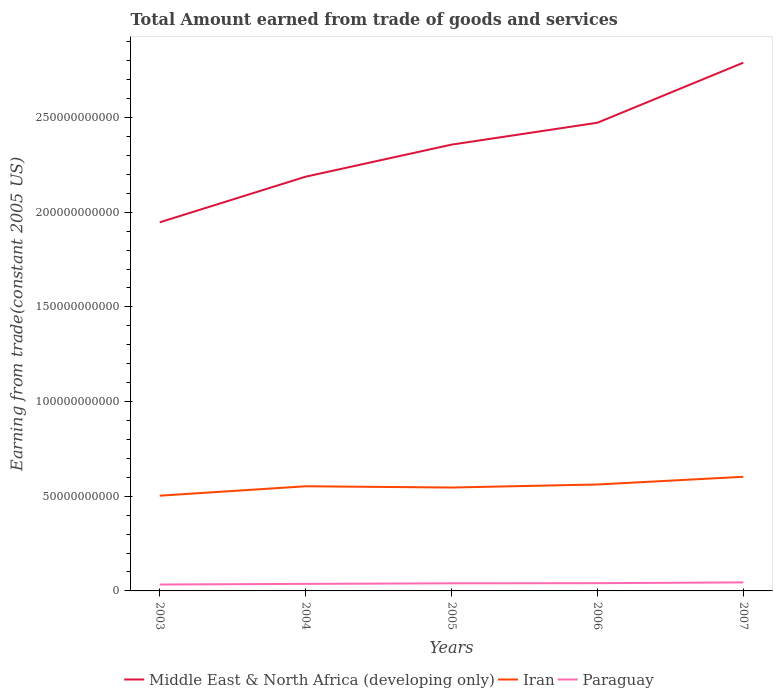How many different coloured lines are there?
Your response must be concise. 3. Across all years, what is the maximum total amount earned by trading goods and services in Middle East & North Africa (developing only)?
Keep it short and to the point. 1.95e+11. What is the total total amount earned by trading goods and services in Paraguay in the graph?
Make the answer very short. -3.79e+08. What is the difference between the highest and the second highest total amount earned by trading goods and services in Middle East & North Africa (developing only)?
Offer a very short reply. 8.43e+1. Is the total amount earned by trading goods and services in Middle East & North Africa (developing only) strictly greater than the total amount earned by trading goods and services in Paraguay over the years?
Keep it short and to the point. No. Does the graph contain any zero values?
Your answer should be very brief. No. Does the graph contain grids?
Your answer should be compact. No. What is the title of the graph?
Provide a succinct answer. Total Amount earned from trade of goods and services. What is the label or title of the Y-axis?
Offer a very short reply. Earning from trade(constant 2005 US). What is the Earning from trade(constant 2005 US) of Middle East & North Africa (developing only) in 2003?
Make the answer very short. 1.95e+11. What is the Earning from trade(constant 2005 US) in Iran in 2003?
Offer a very short reply. 5.03e+1. What is the Earning from trade(constant 2005 US) of Paraguay in 2003?
Provide a short and direct response. 3.38e+09. What is the Earning from trade(constant 2005 US) in Middle East & North Africa (developing only) in 2004?
Make the answer very short. 2.19e+11. What is the Earning from trade(constant 2005 US) of Iran in 2004?
Your response must be concise. 5.53e+1. What is the Earning from trade(constant 2005 US) in Paraguay in 2004?
Ensure brevity in your answer.  3.72e+09. What is the Earning from trade(constant 2005 US) in Middle East & North Africa (developing only) in 2005?
Your answer should be very brief. 2.36e+11. What is the Earning from trade(constant 2005 US) in Iran in 2005?
Your response must be concise. 5.46e+1. What is the Earning from trade(constant 2005 US) of Paraguay in 2005?
Provide a succinct answer. 4.02e+09. What is the Earning from trade(constant 2005 US) in Middle East & North Africa (developing only) in 2006?
Give a very brief answer. 2.47e+11. What is the Earning from trade(constant 2005 US) of Iran in 2006?
Your response must be concise. 5.62e+1. What is the Earning from trade(constant 2005 US) in Paraguay in 2006?
Keep it short and to the point. 4.10e+09. What is the Earning from trade(constant 2005 US) in Middle East & North Africa (developing only) in 2007?
Offer a terse response. 2.79e+11. What is the Earning from trade(constant 2005 US) of Iran in 2007?
Keep it short and to the point. 6.03e+1. What is the Earning from trade(constant 2005 US) of Paraguay in 2007?
Your response must be concise. 4.49e+09. Across all years, what is the maximum Earning from trade(constant 2005 US) of Middle East & North Africa (developing only)?
Offer a very short reply. 2.79e+11. Across all years, what is the maximum Earning from trade(constant 2005 US) of Iran?
Your answer should be very brief. 6.03e+1. Across all years, what is the maximum Earning from trade(constant 2005 US) of Paraguay?
Your answer should be very brief. 4.49e+09. Across all years, what is the minimum Earning from trade(constant 2005 US) of Middle East & North Africa (developing only)?
Offer a very short reply. 1.95e+11. Across all years, what is the minimum Earning from trade(constant 2005 US) in Iran?
Make the answer very short. 5.03e+1. Across all years, what is the minimum Earning from trade(constant 2005 US) of Paraguay?
Your answer should be compact. 3.38e+09. What is the total Earning from trade(constant 2005 US) in Middle East & North Africa (developing only) in the graph?
Provide a short and direct response. 1.18e+12. What is the total Earning from trade(constant 2005 US) of Iran in the graph?
Provide a short and direct response. 2.77e+11. What is the total Earning from trade(constant 2005 US) in Paraguay in the graph?
Make the answer very short. 1.97e+1. What is the difference between the Earning from trade(constant 2005 US) in Middle East & North Africa (developing only) in 2003 and that in 2004?
Your response must be concise. -2.41e+1. What is the difference between the Earning from trade(constant 2005 US) of Iran in 2003 and that in 2004?
Keep it short and to the point. -4.98e+09. What is the difference between the Earning from trade(constant 2005 US) of Paraguay in 2003 and that in 2004?
Ensure brevity in your answer.  -3.34e+08. What is the difference between the Earning from trade(constant 2005 US) in Middle East & North Africa (developing only) in 2003 and that in 2005?
Provide a succinct answer. -4.10e+1. What is the difference between the Earning from trade(constant 2005 US) of Iran in 2003 and that in 2005?
Offer a very short reply. -4.31e+09. What is the difference between the Earning from trade(constant 2005 US) in Paraguay in 2003 and that in 2005?
Provide a short and direct response. -6.34e+08. What is the difference between the Earning from trade(constant 2005 US) in Middle East & North Africa (developing only) in 2003 and that in 2006?
Your answer should be compact. -5.26e+1. What is the difference between the Earning from trade(constant 2005 US) in Iran in 2003 and that in 2006?
Provide a succinct answer. -5.92e+09. What is the difference between the Earning from trade(constant 2005 US) of Paraguay in 2003 and that in 2006?
Make the answer very short. -7.12e+08. What is the difference between the Earning from trade(constant 2005 US) of Middle East & North Africa (developing only) in 2003 and that in 2007?
Keep it short and to the point. -8.43e+1. What is the difference between the Earning from trade(constant 2005 US) of Iran in 2003 and that in 2007?
Ensure brevity in your answer.  -9.98e+09. What is the difference between the Earning from trade(constant 2005 US) of Paraguay in 2003 and that in 2007?
Ensure brevity in your answer.  -1.11e+09. What is the difference between the Earning from trade(constant 2005 US) of Middle East & North Africa (developing only) in 2004 and that in 2005?
Provide a succinct answer. -1.69e+1. What is the difference between the Earning from trade(constant 2005 US) of Iran in 2004 and that in 2005?
Your answer should be compact. 6.70e+08. What is the difference between the Earning from trade(constant 2005 US) of Paraguay in 2004 and that in 2005?
Provide a short and direct response. -3.00e+08. What is the difference between the Earning from trade(constant 2005 US) in Middle East & North Africa (developing only) in 2004 and that in 2006?
Keep it short and to the point. -2.85e+1. What is the difference between the Earning from trade(constant 2005 US) in Iran in 2004 and that in 2006?
Offer a terse response. -9.44e+08. What is the difference between the Earning from trade(constant 2005 US) of Paraguay in 2004 and that in 2006?
Provide a succinct answer. -3.79e+08. What is the difference between the Earning from trade(constant 2005 US) of Middle East & North Africa (developing only) in 2004 and that in 2007?
Your response must be concise. -6.02e+1. What is the difference between the Earning from trade(constant 2005 US) of Iran in 2004 and that in 2007?
Your answer should be compact. -5.00e+09. What is the difference between the Earning from trade(constant 2005 US) in Paraguay in 2004 and that in 2007?
Offer a very short reply. -7.75e+08. What is the difference between the Earning from trade(constant 2005 US) in Middle East & North Africa (developing only) in 2005 and that in 2006?
Offer a very short reply. -1.16e+1. What is the difference between the Earning from trade(constant 2005 US) in Iran in 2005 and that in 2006?
Offer a very short reply. -1.61e+09. What is the difference between the Earning from trade(constant 2005 US) in Paraguay in 2005 and that in 2006?
Offer a terse response. -7.84e+07. What is the difference between the Earning from trade(constant 2005 US) of Middle East & North Africa (developing only) in 2005 and that in 2007?
Provide a short and direct response. -4.33e+1. What is the difference between the Earning from trade(constant 2005 US) of Iran in 2005 and that in 2007?
Offer a terse response. -5.67e+09. What is the difference between the Earning from trade(constant 2005 US) in Paraguay in 2005 and that in 2007?
Offer a terse response. -4.75e+08. What is the difference between the Earning from trade(constant 2005 US) in Middle East & North Africa (developing only) in 2006 and that in 2007?
Your response must be concise. -3.17e+1. What is the difference between the Earning from trade(constant 2005 US) in Iran in 2006 and that in 2007?
Give a very brief answer. -4.06e+09. What is the difference between the Earning from trade(constant 2005 US) of Paraguay in 2006 and that in 2007?
Your answer should be compact. -3.97e+08. What is the difference between the Earning from trade(constant 2005 US) in Middle East & North Africa (developing only) in 2003 and the Earning from trade(constant 2005 US) in Iran in 2004?
Offer a very short reply. 1.39e+11. What is the difference between the Earning from trade(constant 2005 US) of Middle East & North Africa (developing only) in 2003 and the Earning from trade(constant 2005 US) of Paraguay in 2004?
Keep it short and to the point. 1.91e+11. What is the difference between the Earning from trade(constant 2005 US) in Iran in 2003 and the Earning from trade(constant 2005 US) in Paraguay in 2004?
Provide a short and direct response. 4.66e+1. What is the difference between the Earning from trade(constant 2005 US) of Middle East & North Africa (developing only) in 2003 and the Earning from trade(constant 2005 US) of Iran in 2005?
Provide a succinct answer. 1.40e+11. What is the difference between the Earning from trade(constant 2005 US) of Middle East & North Africa (developing only) in 2003 and the Earning from trade(constant 2005 US) of Paraguay in 2005?
Provide a succinct answer. 1.91e+11. What is the difference between the Earning from trade(constant 2005 US) in Iran in 2003 and the Earning from trade(constant 2005 US) in Paraguay in 2005?
Offer a terse response. 4.63e+1. What is the difference between the Earning from trade(constant 2005 US) of Middle East & North Africa (developing only) in 2003 and the Earning from trade(constant 2005 US) of Iran in 2006?
Provide a succinct answer. 1.38e+11. What is the difference between the Earning from trade(constant 2005 US) in Middle East & North Africa (developing only) in 2003 and the Earning from trade(constant 2005 US) in Paraguay in 2006?
Your answer should be compact. 1.91e+11. What is the difference between the Earning from trade(constant 2005 US) in Iran in 2003 and the Earning from trade(constant 2005 US) in Paraguay in 2006?
Make the answer very short. 4.62e+1. What is the difference between the Earning from trade(constant 2005 US) in Middle East & North Africa (developing only) in 2003 and the Earning from trade(constant 2005 US) in Iran in 2007?
Keep it short and to the point. 1.34e+11. What is the difference between the Earning from trade(constant 2005 US) in Middle East & North Africa (developing only) in 2003 and the Earning from trade(constant 2005 US) in Paraguay in 2007?
Give a very brief answer. 1.90e+11. What is the difference between the Earning from trade(constant 2005 US) of Iran in 2003 and the Earning from trade(constant 2005 US) of Paraguay in 2007?
Keep it short and to the point. 4.58e+1. What is the difference between the Earning from trade(constant 2005 US) of Middle East & North Africa (developing only) in 2004 and the Earning from trade(constant 2005 US) of Iran in 2005?
Keep it short and to the point. 1.64e+11. What is the difference between the Earning from trade(constant 2005 US) of Middle East & North Africa (developing only) in 2004 and the Earning from trade(constant 2005 US) of Paraguay in 2005?
Your answer should be compact. 2.15e+11. What is the difference between the Earning from trade(constant 2005 US) of Iran in 2004 and the Earning from trade(constant 2005 US) of Paraguay in 2005?
Offer a terse response. 5.12e+1. What is the difference between the Earning from trade(constant 2005 US) of Middle East & North Africa (developing only) in 2004 and the Earning from trade(constant 2005 US) of Iran in 2006?
Provide a succinct answer. 1.63e+11. What is the difference between the Earning from trade(constant 2005 US) in Middle East & North Africa (developing only) in 2004 and the Earning from trade(constant 2005 US) in Paraguay in 2006?
Offer a very short reply. 2.15e+11. What is the difference between the Earning from trade(constant 2005 US) of Iran in 2004 and the Earning from trade(constant 2005 US) of Paraguay in 2006?
Give a very brief answer. 5.12e+1. What is the difference between the Earning from trade(constant 2005 US) in Middle East & North Africa (developing only) in 2004 and the Earning from trade(constant 2005 US) in Iran in 2007?
Make the answer very short. 1.58e+11. What is the difference between the Earning from trade(constant 2005 US) in Middle East & North Africa (developing only) in 2004 and the Earning from trade(constant 2005 US) in Paraguay in 2007?
Offer a very short reply. 2.14e+11. What is the difference between the Earning from trade(constant 2005 US) in Iran in 2004 and the Earning from trade(constant 2005 US) in Paraguay in 2007?
Your response must be concise. 5.08e+1. What is the difference between the Earning from trade(constant 2005 US) in Middle East & North Africa (developing only) in 2005 and the Earning from trade(constant 2005 US) in Iran in 2006?
Keep it short and to the point. 1.79e+11. What is the difference between the Earning from trade(constant 2005 US) of Middle East & North Africa (developing only) in 2005 and the Earning from trade(constant 2005 US) of Paraguay in 2006?
Ensure brevity in your answer.  2.32e+11. What is the difference between the Earning from trade(constant 2005 US) in Iran in 2005 and the Earning from trade(constant 2005 US) in Paraguay in 2006?
Make the answer very short. 5.05e+1. What is the difference between the Earning from trade(constant 2005 US) of Middle East & North Africa (developing only) in 2005 and the Earning from trade(constant 2005 US) of Iran in 2007?
Ensure brevity in your answer.  1.75e+11. What is the difference between the Earning from trade(constant 2005 US) in Middle East & North Africa (developing only) in 2005 and the Earning from trade(constant 2005 US) in Paraguay in 2007?
Offer a terse response. 2.31e+11. What is the difference between the Earning from trade(constant 2005 US) in Iran in 2005 and the Earning from trade(constant 2005 US) in Paraguay in 2007?
Provide a succinct answer. 5.01e+1. What is the difference between the Earning from trade(constant 2005 US) in Middle East & North Africa (developing only) in 2006 and the Earning from trade(constant 2005 US) in Iran in 2007?
Make the answer very short. 1.87e+11. What is the difference between the Earning from trade(constant 2005 US) in Middle East & North Africa (developing only) in 2006 and the Earning from trade(constant 2005 US) in Paraguay in 2007?
Provide a succinct answer. 2.43e+11. What is the difference between the Earning from trade(constant 2005 US) of Iran in 2006 and the Earning from trade(constant 2005 US) of Paraguay in 2007?
Make the answer very short. 5.17e+1. What is the average Earning from trade(constant 2005 US) of Middle East & North Africa (developing only) per year?
Provide a succinct answer. 2.35e+11. What is the average Earning from trade(constant 2005 US) in Iran per year?
Provide a succinct answer. 5.53e+1. What is the average Earning from trade(constant 2005 US) of Paraguay per year?
Your response must be concise. 3.94e+09. In the year 2003, what is the difference between the Earning from trade(constant 2005 US) of Middle East & North Africa (developing only) and Earning from trade(constant 2005 US) of Iran?
Keep it short and to the point. 1.44e+11. In the year 2003, what is the difference between the Earning from trade(constant 2005 US) in Middle East & North Africa (developing only) and Earning from trade(constant 2005 US) in Paraguay?
Offer a terse response. 1.91e+11. In the year 2003, what is the difference between the Earning from trade(constant 2005 US) in Iran and Earning from trade(constant 2005 US) in Paraguay?
Give a very brief answer. 4.69e+1. In the year 2004, what is the difference between the Earning from trade(constant 2005 US) of Middle East & North Africa (developing only) and Earning from trade(constant 2005 US) of Iran?
Offer a very short reply. 1.63e+11. In the year 2004, what is the difference between the Earning from trade(constant 2005 US) of Middle East & North Africa (developing only) and Earning from trade(constant 2005 US) of Paraguay?
Offer a very short reply. 2.15e+11. In the year 2004, what is the difference between the Earning from trade(constant 2005 US) of Iran and Earning from trade(constant 2005 US) of Paraguay?
Provide a succinct answer. 5.15e+1. In the year 2005, what is the difference between the Earning from trade(constant 2005 US) in Middle East & North Africa (developing only) and Earning from trade(constant 2005 US) in Iran?
Your answer should be very brief. 1.81e+11. In the year 2005, what is the difference between the Earning from trade(constant 2005 US) of Middle East & North Africa (developing only) and Earning from trade(constant 2005 US) of Paraguay?
Ensure brevity in your answer.  2.32e+11. In the year 2005, what is the difference between the Earning from trade(constant 2005 US) of Iran and Earning from trade(constant 2005 US) of Paraguay?
Provide a succinct answer. 5.06e+1. In the year 2006, what is the difference between the Earning from trade(constant 2005 US) of Middle East & North Africa (developing only) and Earning from trade(constant 2005 US) of Iran?
Ensure brevity in your answer.  1.91e+11. In the year 2006, what is the difference between the Earning from trade(constant 2005 US) of Middle East & North Africa (developing only) and Earning from trade(constant 2005 US) of Paraguay?
Your answer should be very brief. 2.43e+11. In the year 2006, what is the difference between the Earning from trade(constant 2005 US) in Iran and Earning from trade(constant 2005 US) in Paraguay?
Your response must be concise. 5.21e+1. In the year 2007, what is the difference between the Earning from trade(constant 2005 US) in Middle East & North Africa (developing only) and Earning from trade(constant 2005 US) in Iran?
Provide a short and direct response. 2.19e+11. In the year 2007, what is the difference between the Earning from trade(constant 2005 US) in Middle East & North Africa (developing only) and Earning from trade(constant 2005 US) in Paraguay?
Your response must be concise. 2.74e+11. In the year 2007, what is the difference between the Earning from trade(constant 2005 US) of Iran and Earning from trade(constant 2005 US) of Paraguay?
Your response must be concise. 5.58e+1. What is the ratio of the Earning from trade(constant 2005 US) in Middle East & North Africa (developing only) in 2003 to that in 2004?
Ensure brevity in your answer.  0.89. What is the ratio of the Earning from trade(constant 2005 US) of Iran in 2003 to that in 2004?
Offer a very short reply. 0.91. What is the ratio of the Earning from trade(constant 2005 US) in Paraguay in 2003 to that in 2004?
Keep it short and to the point. 0.91. What is the ratio of the Earning from trade(constant 2005 US) in Middle East & North Africa (developing only) in 2003 to that in 2005?
Give a very brief answer. 0.83. What is the ratio of the Earning from trade(constant 2005 US) of Iran in 2003 to that in 2005?
Offer a terse response. 0.92. What is the ratio of the Earning from trade(constant 2005 US) of Paraguay in 2003 to that in 2005?
Your response must be concise. 0.84. What is the ratio of the Earning from trade(constant 2005 US) of Middle East & North Africa (developing only) in 2003 to that in 2006?
Give a very brief answer. 0.79. What is the ratio of the Earning from trade(constant 2005 US) in Iran in 2003 to that in 2006?
Offer a terse response. 0.89. What is the ratio of the Earning from trade(constant 2005 US) of Paraguay in 2003 to that in 2006?
Make the answer very short. 0.83. What is the ratio of the Earning from trade(constant 2005 US) in Middle East & North Africa (developing only) in 2003 to that in 2007?
Give a very brief answer. 0.7. What is the ratio of the Earning from trade(constant 2005 US) of Iran in 2003 to that in 2007?
Provide a short and direct response. 0.83. What is the ratio of the Earning from trade(constant 2005 US) of Paraguay in 2003 to that in 2007?
Your answer should be compact. 0.75. What is the ratio of the Earning from trade(constant 2005 US) in Middle East & North Africa (developing only) in 2004 to that in 2005?
Offer a very short reply. 0.93. What is the ratio of the Earning from trade(constant 2005 US) in Iran in 2004 to that in 2005?
Your answer should be very brief. 1.01. What is the ratio of the Earning from trade(constant 2005 US) of Paraguay in 2004 to that in 2005?
Offer a very short reply. 0.93. What is the ratio of the Earning from trade(constant 2005 US) in Middle East & North Africa (developing only) in 2004 to that in 2006?
Provide a short and direct response. 0.88. What is the ratio of the Earning from trade(constant 2005 US) of Iran in 2004 to that in 2006?
Your answer should be very brief. 0.98. What is the ratio of the Earning from trade(constant 2005 US) of Paraguay in 2004 to that in 2006?
Your response must be concise. 0.91. What is the ratio of the Earning from trade(constant 2005 US) of Middle East & North Africa (developing only) in 2004 to that in 2007?
Keep it short and to the point. 0.78. What is the ratio of the Earning from trade(constant 2005 US) in Iran in 2004 to that in 2007?
Offer a terse response. 0.92. What is the ratio of the Earning from trade(constant 2005 US) in Paraguay in 2004 to that in 2007?
Your response must be concise. 0.83. What is the ratio of the Earning from trade(constant 2005 US) in Middle East & North Africa (developing only) in 2005 to that in 2006?
Ensure brevity in your answer.  0.95. What is the ratio of the Earning from trade(constant 2005 US) in Iran in 2005 to that in 2006?
Make the answer very short. 0.97. What is the ratio of the Earning from trade(constant 2005 US) of Paraguay in 2005 to that in 2006?
Offer a terse response. 0.98. What is the ratio of the Earning from trade(constant 2005 US) in Middle East & North Africa (developing only) in 2005 to that in 2007?
Keep it short and to the point. 0.84. What is the ratio of the Earning from trade(constant 2005 US) of Iran in 2005 to that in 2007?
Provide a short and direct response. 0.91. What is the ratio of the Earning from trade(constant 2005 US) of Paraguay in 2005 to that in 2007?
Your answer should be very brief. 0.89. What is the ratio of the Earning from trade(constant 2005 US) of Middle East & North Africa (developing only) in 2006 to that in 2007?
Your response must be concise. 0.89. What is the ratio of the Earning from trade(constant 2005 US) of Iran in 2006 to that in 2007?
Offer a very short reply. 0.93. What is the ratio of the Earning from trade(constant 2005 US) in Paraguay in 2006 to that in 2007?
Provide a succinct answer. 0.91. What is the difference between the highest and the second highest Earning from trade(constant 2005 US) of Middle East & North Africa (developing only)?
Offer a terse response. 3.17e+1. What is the difference between the highest and the second highest Earning from trade(constant 2005 US) of Iran?
Your answer should be very brief. 4.06e+09. What is the difference between the highest and the second highest Earning from trade(constant 2005 US) of Paraguay?
Offer a terse response. 3.97e+08. What is the difference between the highest and the lowest Earning from trade(constant 2005 US) in Middle East & North Africa (developing only)?
Provide a succinct answer. 8.43e+1. What is the difference between the highest and the lowest Earning from trade(constant 2005 US) in Iran?
Offer a very short reply. 9.98e+09. What is the difference between the highest and the lowest Earning from trade(constant 2005 US) in Paraguay?
Your answer should be compact. 1.11e+09. 